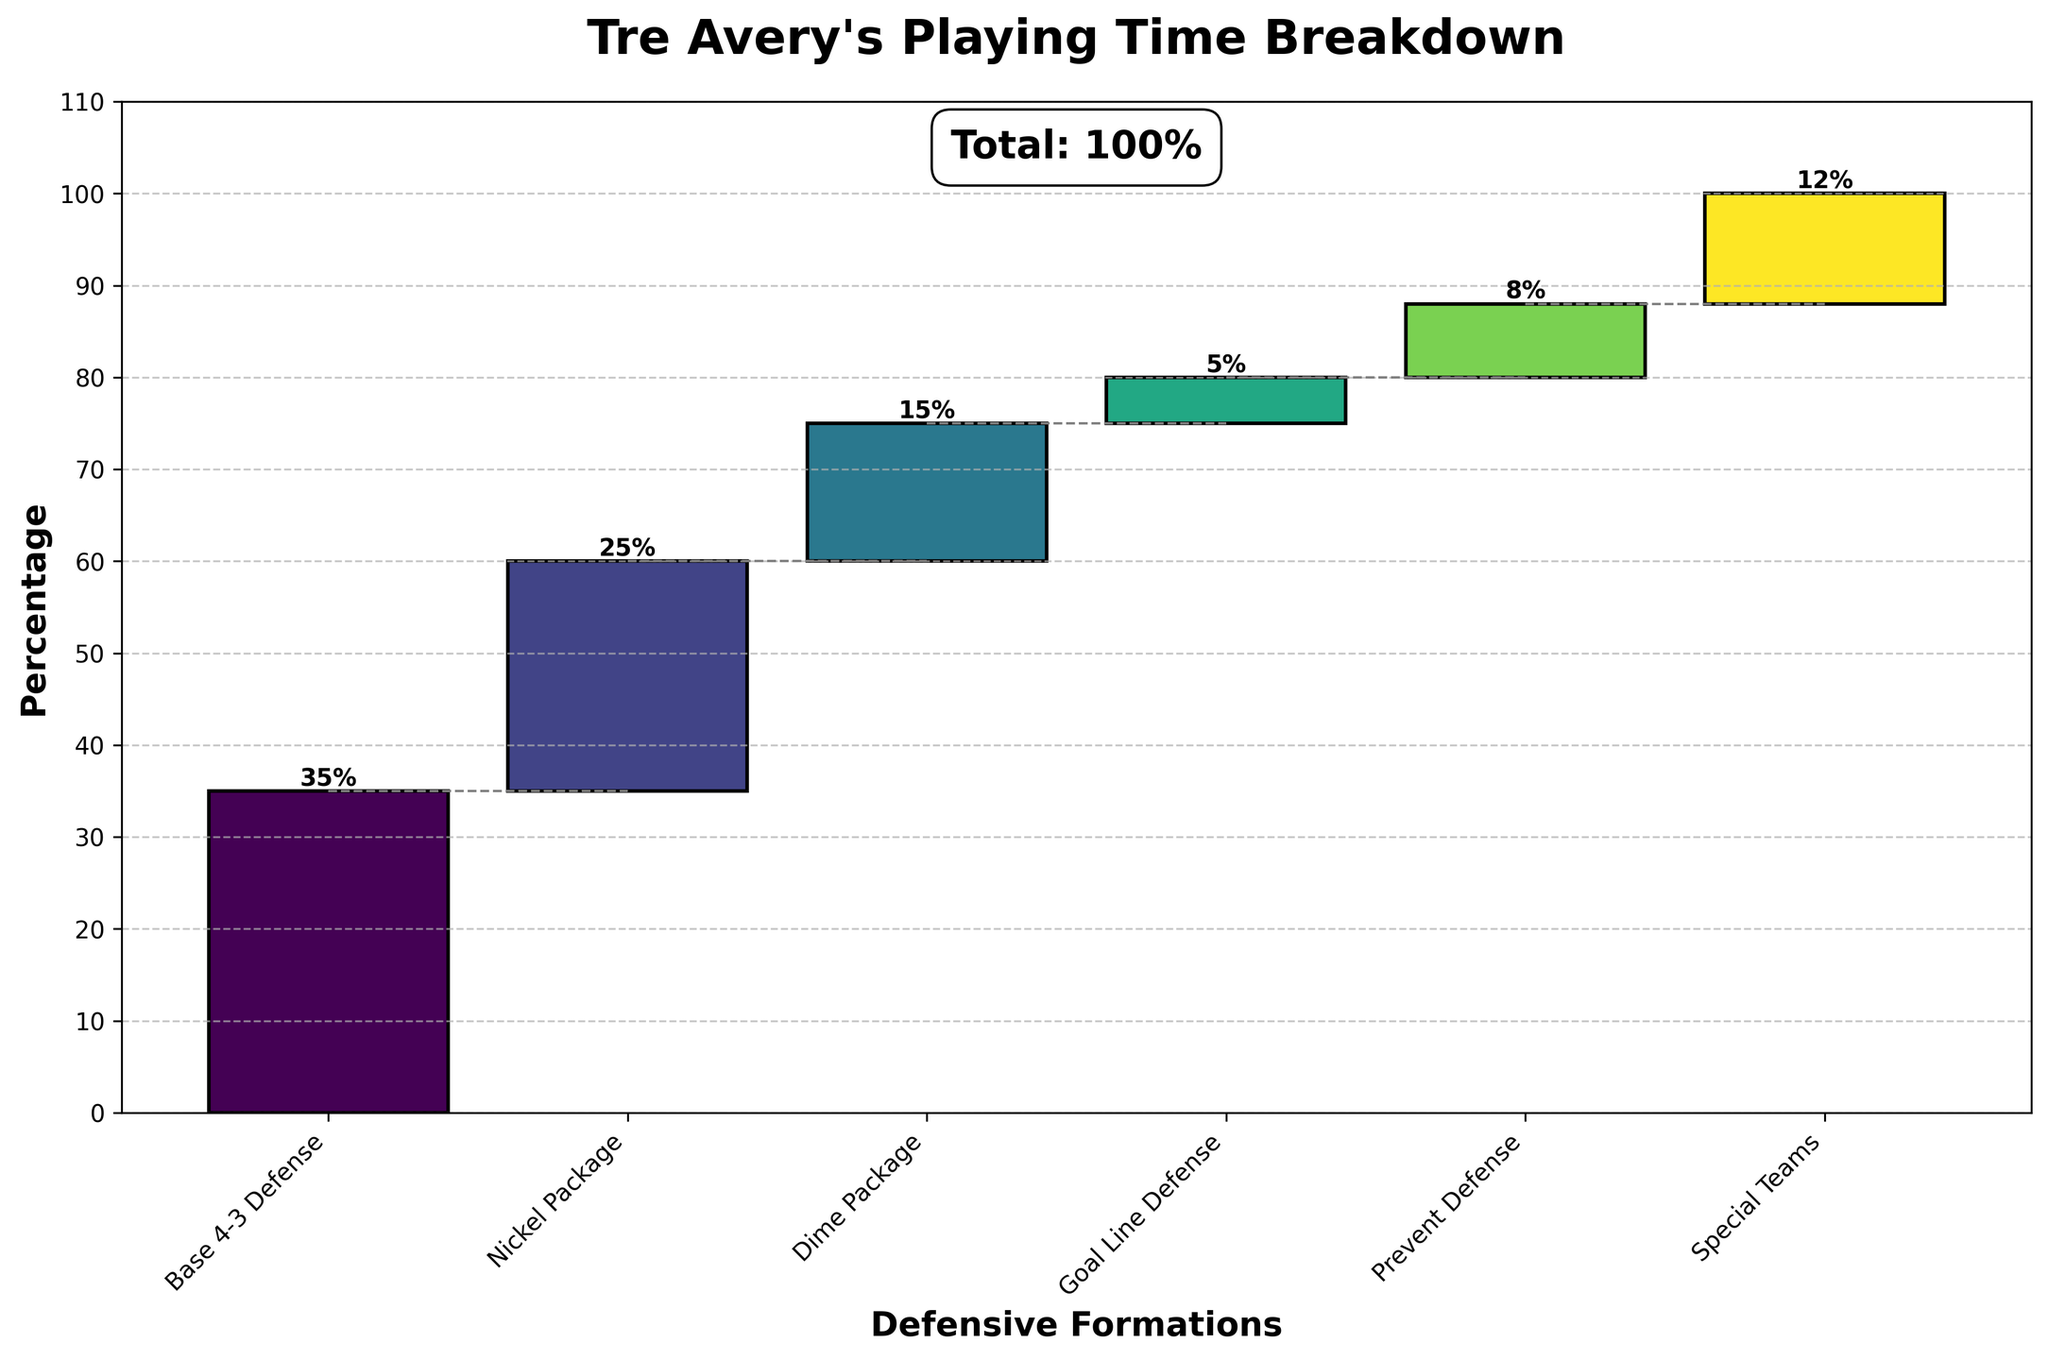What is the title of the chart? The title is usually displayed at the top of the figure, and it provides a summary of the information being presented. In this case, it helps understand the context immediately.
Answer: Tre Avery's Playing Time Breakdown Which defensive formation has the highest percentage of playing time? By observing the length of each bar, the highest one represents the formation with the largest percentage. In this chart, 'Base 4-3 Defense' has the longest bar.
Answer: Base 4-3 Defense How much playing time does the Nickel Package formation account for? Each bar is labeled with its percentage on the chart, so you can directly read 'Nickel Package' to find its label.
Answer: 25% What is the difference in playing time between Dime Package and Special Teams? Locate the bars for 'Dime Package' and 'Special Teams,' note their percentages (15% and 12% respectively), and subtract one from the other.
Answer: 3% If Base 4-3 Defense and Nickel Package are combined, what percentage of playing time do they account for? Add the percentages of Base 4-3 Defense (35%) and Nickel Package (25%). The sum gives the combined percentage.
Answer: 60% Which formation accounts for the least amount of playing time? By looking at the shortest bar, which represents the smallest percentage, you can identify which formation has the least playing time. Here, it's 'Goal Line Defense'.
Answer: Goal Line Defense How much total playing time is covered by Goal Line and Prevent Defense? Add the percentages of Goal Line Defense (5%) and Prevent Defense (8%) to find the total playing time for these formations combined.
Answer: 13% Are Special Teams used more or less frequently than Prevent Defense? Compare the heights or the percentage labels of 'Special Teams' and 'Prevent Defense' bars. Special Teams have 12%, while Prevent Defense has 8%.
Answer: More What is the cumulative playing time percentage just before the Special Teams formation? To find this, note the cumulative percentages displayed before Special Teams. Sum the percentages of all formations up to but not including Special Teams.
Answer: 80% How much more playing time does the Base 4-3 Defense have compared to Dime Package? Subtract the percentage of the Dime Package (15%) from the Base 4-3 Defense (35%).
Answer: 20% 